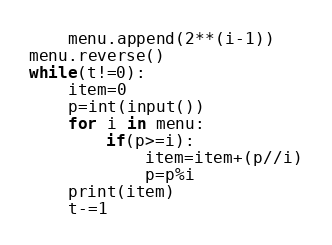<code> <loc_0><loc_0><loc_500><loc_500><_Python_>    menu.append(2**(i-1))
menu.reverse()   
while(t!=0):
    item=0
    p=int(input())
    for i in menu:
        if(p>=i):
            item=item+(p//i)
            p=p%i 
    print(item)
    t-=1
</code> 